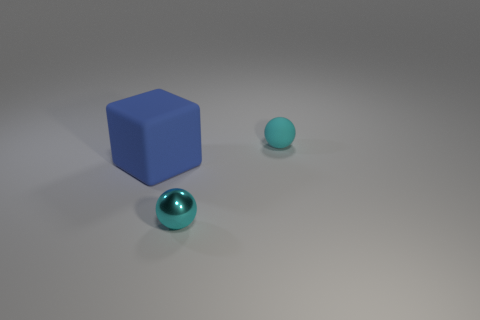Does the matte thing that is behind the blue block have the same color as the small metallic thing?
Ensure brevity in your answer.  Yes. How many small metallic spheres have the same color as the tiny rubber ball?
Your response must be concise. 1. Are there fewer small cyan balls behind the cyan rubber object than objects in front of the blue thing?
Provide a short and direct response. Yes. There is a cyan rubber object; is it the same size as the sphere that is in front of the matte block?
Offer a terse response. Yes. The object that is both behind the tiny cyan shiny thing and right of the large blue object has what shape?
Offer a terse response. Sphere. There is a thing that is made of the same material as the block; what size is it?
Give a very brief answer. Small. There is a thing that is in front of the blue block; how many tiny matte balls are behind it?
Offer a very short reply. 1. Does the cyan object in front of the blue block have the same material as the big blue cube?
Your answer should be compact. No. There is a ball that is in front of the small cyan sphere behind the big blue object; what size is it?
Offer a terse response. Small. There is a rubber thing to the left of the small cyan ball to the left of the matte thing behind the blue thing; what is its size?
Make the answer very short. Large. 